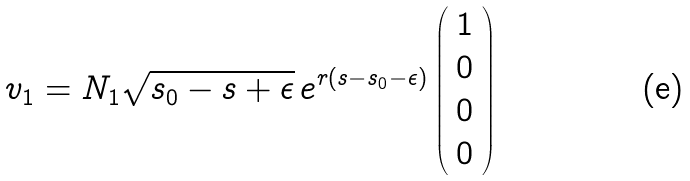Convert formula to latex. <formula><loc_0><loc_0><loc_500><loc_500>v _ { 1 } = N _ { 1 } \sqrt { s _ { 0 } - s + \epsilon } \, e ^ { r ( s - s _ { 0 } - \epsilon ) } \left ( \begin{array} { c } 1 \\ 0 \\ 0 \\ 0 \end{array} \right )</formula> 